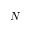<formula> <loc_0><loc_0><loc_500><loc_500>N</formula> 